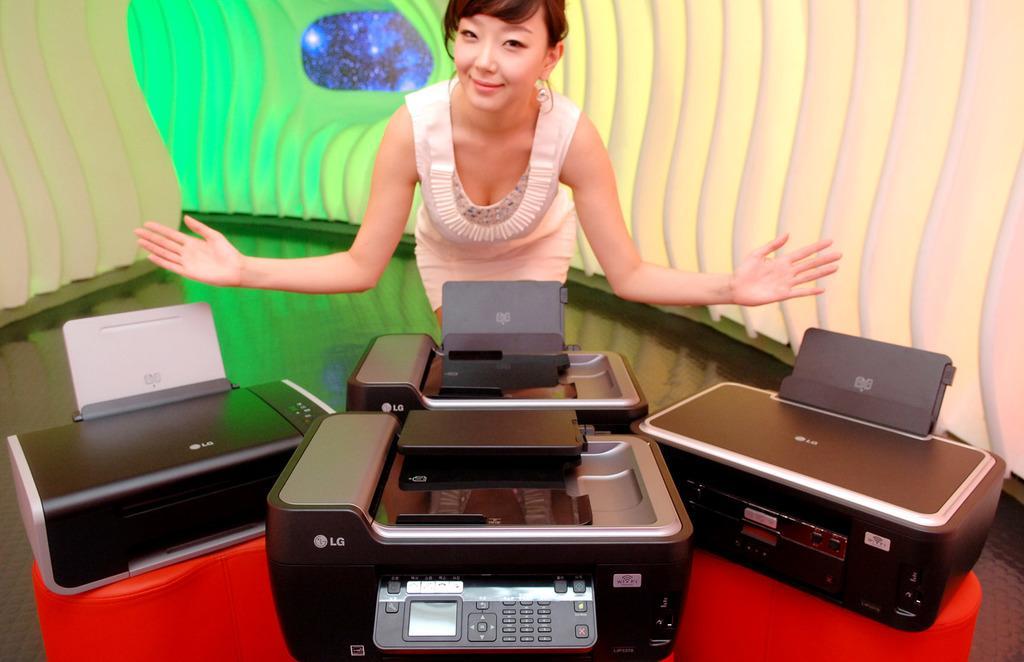How would you summarize this image in a sentence or two? At the bottom of this image, there are electronic devices placed on a red color object. Behind them, there is a woman in a white color dress smiling and bending. In the background, there is a white color surface. 